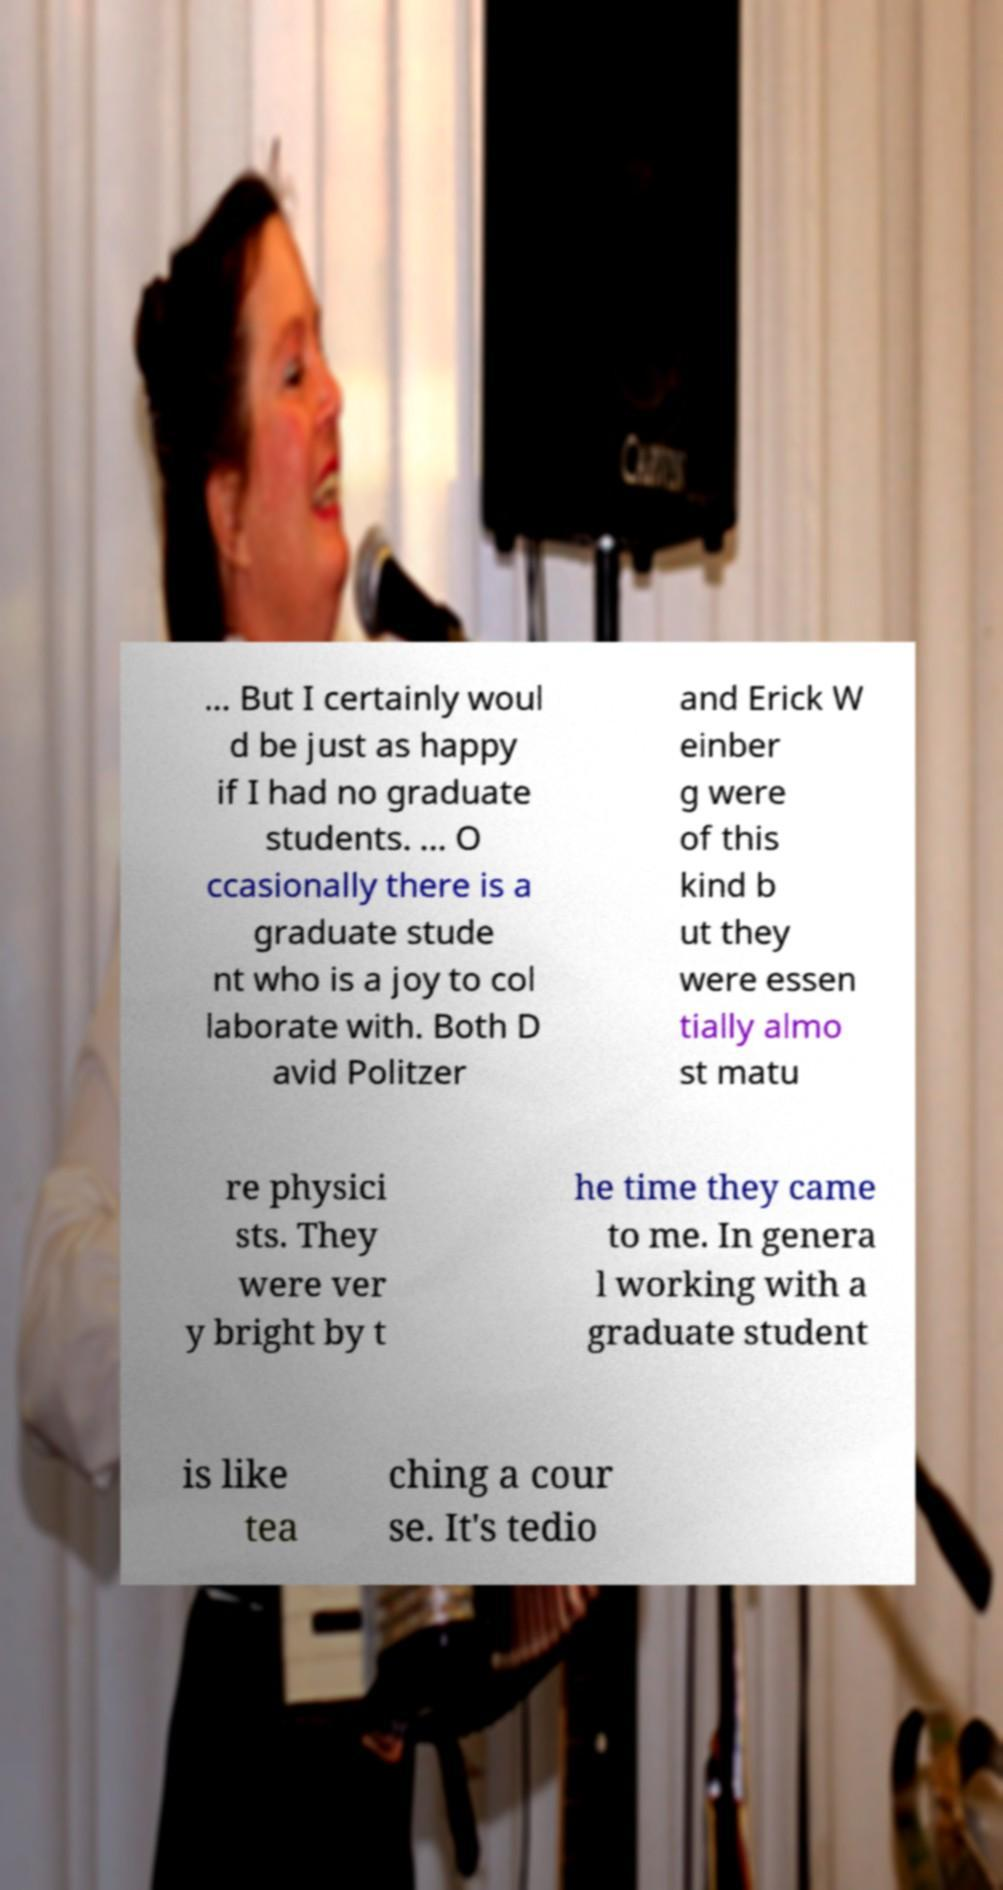What messages or text are displayed in this image? I need them in a readable, typed format. ... But I certainly woul d be just as happy if I had no graduate students. ... O ccasionally there is a graduate stude nt who is a joy to col laborate with. Both D avid Politzer and Erick W einber g were of this kind b ut they were essen tially almo st matu re physici sts. They were ver y bright by t he time they came to me. In genera l working with a graduate student is like tea ching a cour se. It's tedio 